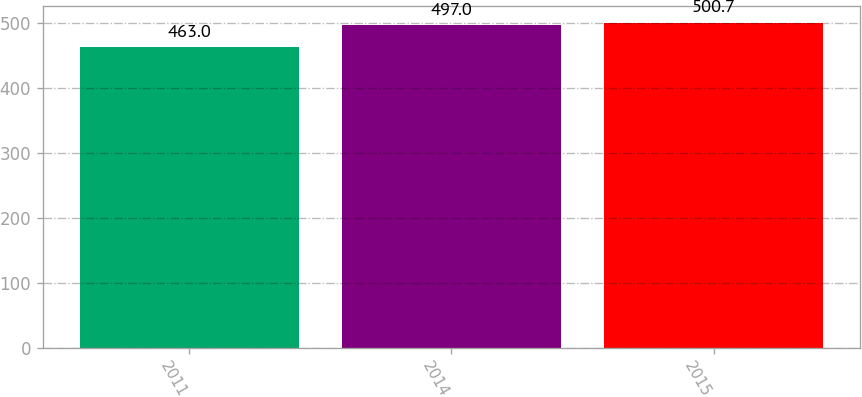<chart> <loc_0><loc_0><loc_500><loc_500><bar_chart><fcel>2011<fcel>2014<fcel>2015<nl><fcel>463<fcel>497<fcel>500.7<nl></chart> 